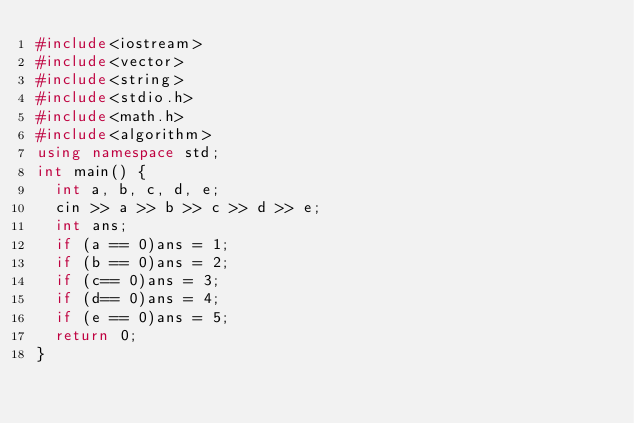Convert code to text. <code><loc_0><loc_0><loc_500><loc_500><_C++_>#include<iostream>
#include<vector>
#include<string>
#include<stdio.h>
#include<math.h>
#include<algorithm>
using namespace std;
int main() {
	int a, b, c, d, e;
	cin >> a >> b >> c >> d >> e;
	int ans;
	if (a == 0)ans = 1;
	if (b == 0)ans = 2;
	if (c== 0)ans = 3;
	if (d== 0)ans = 4;
	if (e == 0)ans = 5;
	return 0;
}</code> 